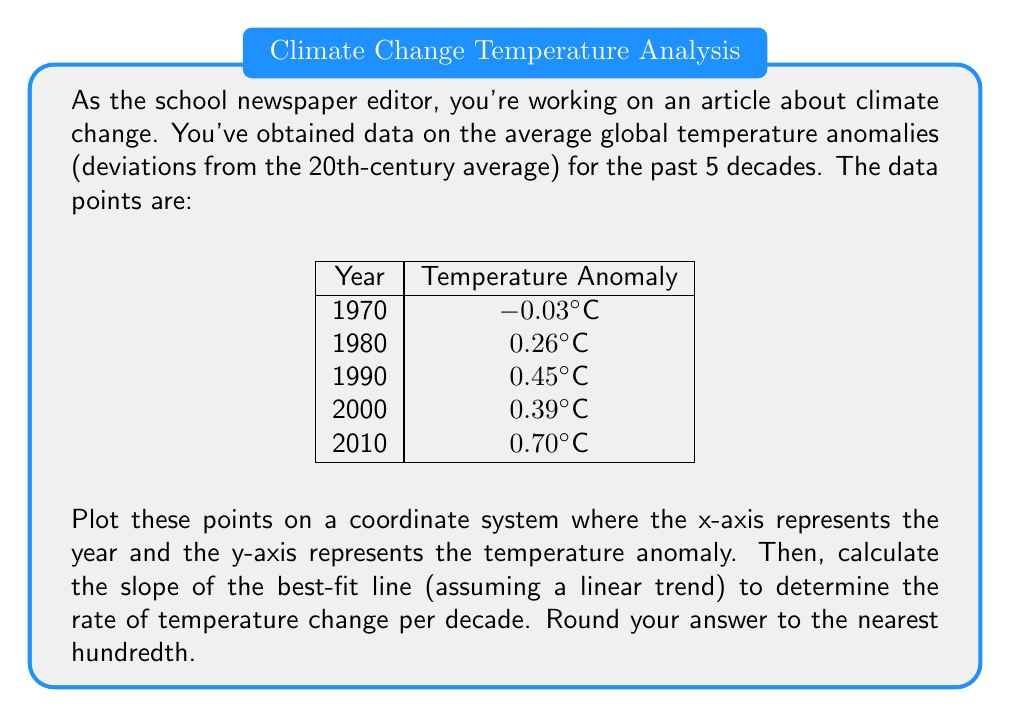Teach me how to tackle this problem. To solve this problem, we'll follow these steps:

1. Plot the points on a coordinate system.
2. Calculate the slope of the best-fit line using the least squares method.

Step 1: Plotting the points

We can plot these points on a coordinate system where:
- x-axis represents the year (1970 to 2010)
- y-axis represents the temperature anomaly (-0.1°C to 0.8°C)

[asy]
size(200,200);
import graph;

xaxis("Year",Ticks(Label(),2));
yaxis("Temperature Anomaly (°C)",Ticks(Label(),2));

real[] x = {1970,1980,1990,2000,2010};
real[] y = {-0.03,0.26,0.45,0.39,0.70};

for(int i=0; i<5; ++i) {
  dot((x[i],y[i]));
}
[/asy]

Step 2: Calculating the slope of the best-fit line

To calculate the slope of the best-fit line, we'll use the least squares method formula:

$$ m = \frac{n\sum xy - \sum x \sum y}{n\sum x^2 - (\sum x)^2} $$

Where:
$n$ is the number of data points
$x$ represents the years
$y$ represents the temperature anomalies

Let's calculate the required sums:

$n = 5$
$\sum x = 1970 + 1980 + 1990 + 2000 + 2010 = 9950$
$\sum y = -0.03 + 0.26 + 0.45 + 0.39 + 0.70 = 1.77$
$\sum xy = (1970 \times -0.03) + (1980 \times 0.26) + (1990 \times 0.45) + (2000 \times 0.39) + (2010 \times 0.70) = 3551.10$
$\sum x^2 = 1970^2 + 1980^2 + 1990^2 + 2000^2 + 2010^2 = 19,800,500$

Now, let's substitute these values into the slope formula:

$$ m = \frac{5(3551.10) - (9950)(1.77)}{5(19,800,500) - (9950)^2} $$

$$ m = \frac{17755.50 - 17611.50}{99,002,500 - 99,002,500} $$

$$ m = \frac{144}{2,500} = 0.0576 $$

The slope represents the rate of temperature change per year. To convert this to the rate per decade, we multiply by 10:

$$ \text{Rate per decade} = 0.0576 \times 10 = 0.576 \text{°C/decade} $$

Rounding to the nearest hundredth, we get 0.58°C/decade.
Answer: 0.58°C/decade 